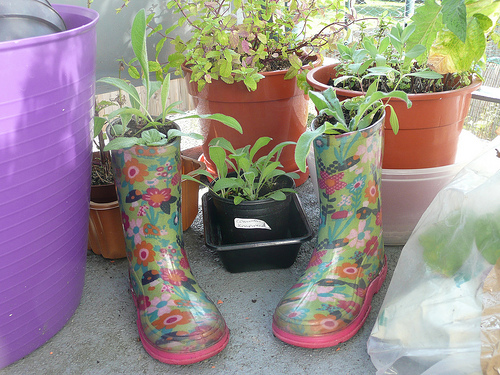<image>
Is the plastic pot to the right of the shoe pot? No. The plastic pot is not to the right of the shoe pot. The horizontal positioning shows a different relationship. 